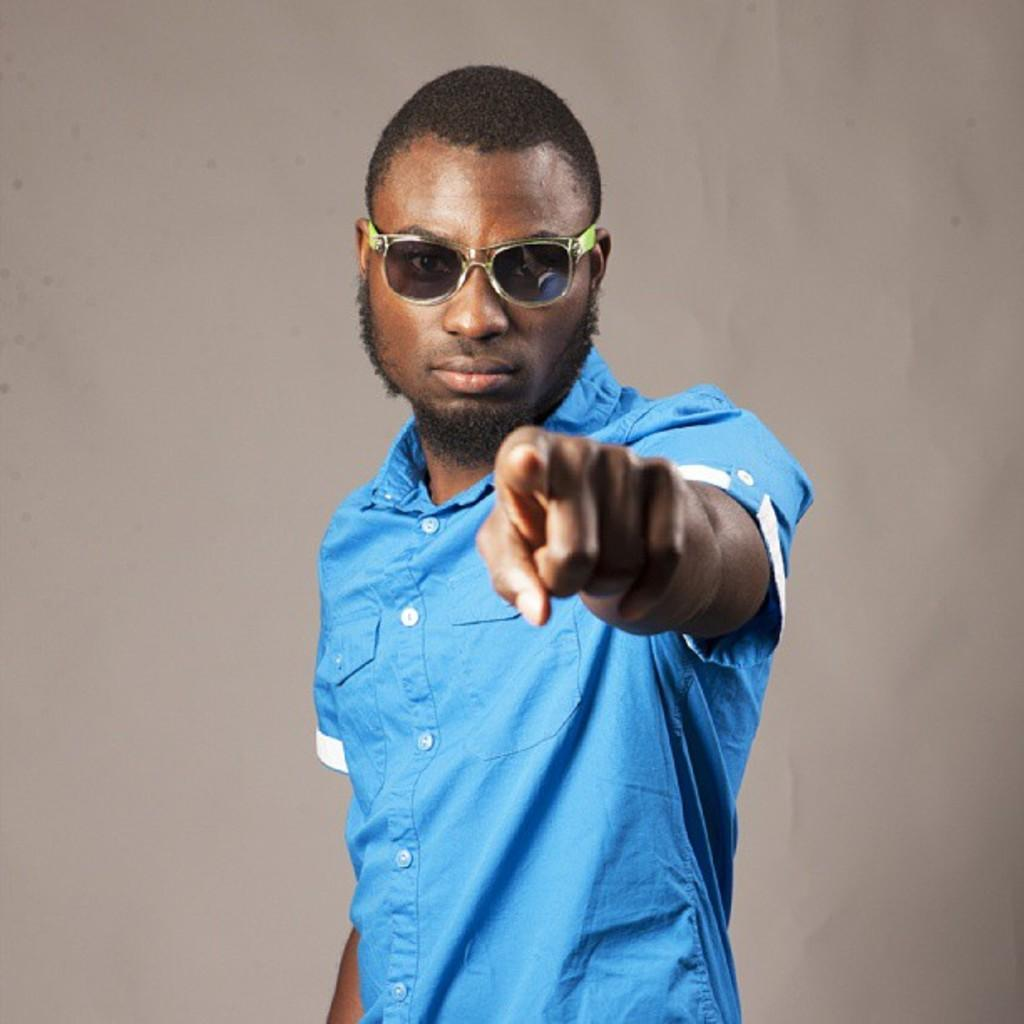Where was the image taken? The image is taken indoors. What can be seen in the background of the image? There is a wall in the background of the image. Who is the main subject in the image? There is a man in the middle of the image. What is the man wearing? The man is wearing a blue shirt. What accessory is the man wearing on his face? The man is wearing glasses (google). What type of brick is the man using for arithmetic in the image? There is no brick or arithmetic activity present in the image. The man is wearing glasses, not using a brick for any purpose. 